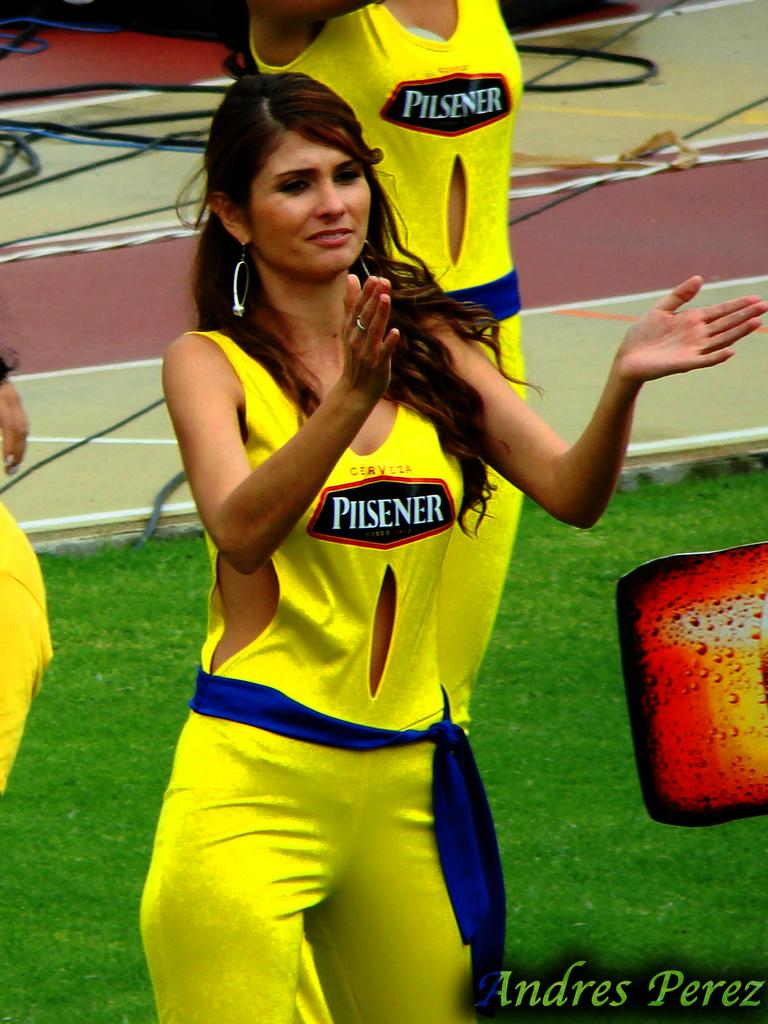<image>
Give a short and clear explanation of the subsequent image. A woman is wearing a yellow outfit with Pilsener advertised on it 